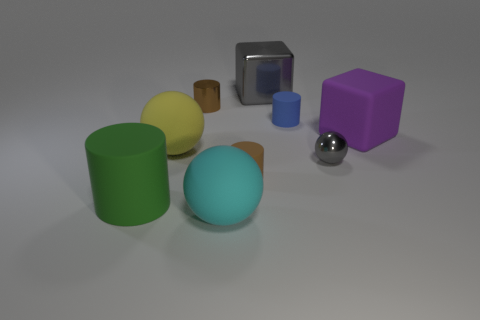Subtract all large cyan matte spheres. How many spheres are left? 2 Add 1 gray objects. How many objects exist? 10 Subtract all cyan spheres. How many brown cylinders are left? 2 Subtract all blocks. How many objects are left? 7 Subtract all blue cylinders. How many cylinders are left? 3 Add 4 big gray things. How many big gray things are left? 5 Add 8 gray metallic spheres. How many gray metallic spheres exist? 9 Subtract 0 green cubes. How many objects are left? 9 Subtract all yellow cylinders. Subtract all brown balls. How many cylinders are left? 4 Subtract all tiny green metallic objects. Subtract all tiny gray objects. How many objects are left? 8 